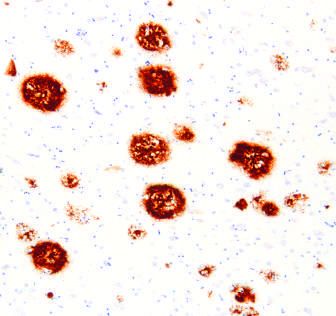s the colon present in the core of the plaques as well as in the surrounding region?
Answer the question using a single word or phrase. No 